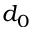<formula> <loc_0><loc_0><loc_500><loc_500>d _ { 0 }</formula> 